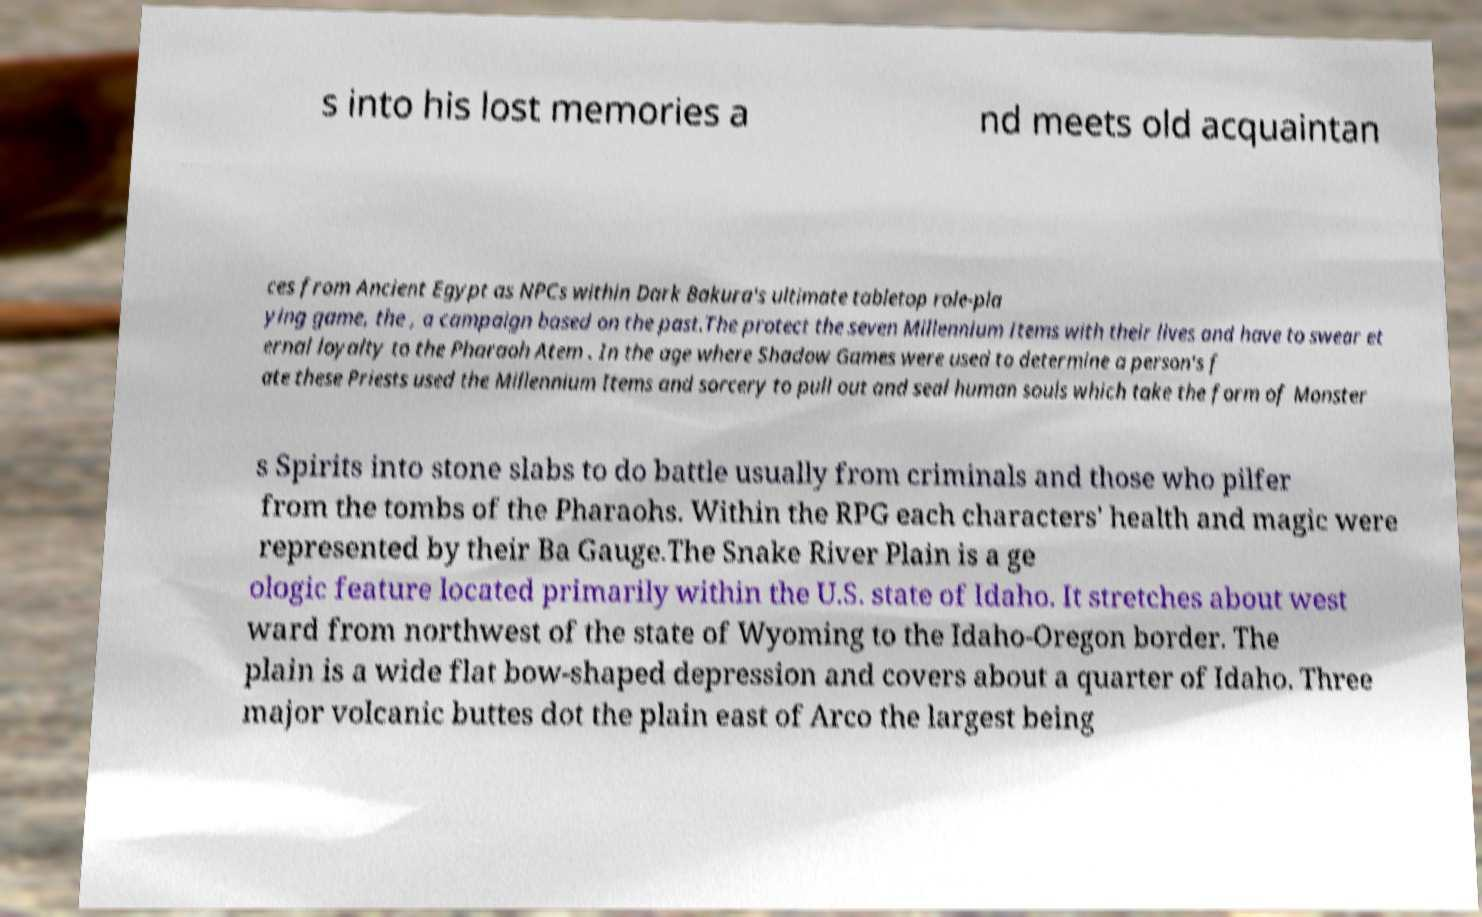There's text embedded in this image that I need extracted. Can you transcribe it verbatim? s into his lost memories a nd meets old acquaintan ces from Ancient Egypt as NPCs within Dark Bakura's ultimate tabletop role-pla ying game, the , a campaign based on the past.The protect the seven Millennium Items with their lives and have to swear et ernal loyalty to the Pharaoh Atem . In the age where Shadow Games were used to determine a person's f ate these Priests used the Millennium Items and sorcery to pull out and seal human souls which take the form of Monster s Spirits into stone slabs to do battle usually from criminals and those who pilfer from the tombs of the Pharaohs. Within the RPG each characters' health and magic were represented by their Ba Gauge.The Snake River Plain is a ge ologic feature located primarily within the U.S. state of Idaho. It stretches about west ward from northwest of the state of Wyoming to the Idaho-Oregon border. The plain is a wide flat bow-shaped depression and covers about a quarter of Idaho. Three major volcanic buttes dot the plain east of Arco the largest being 